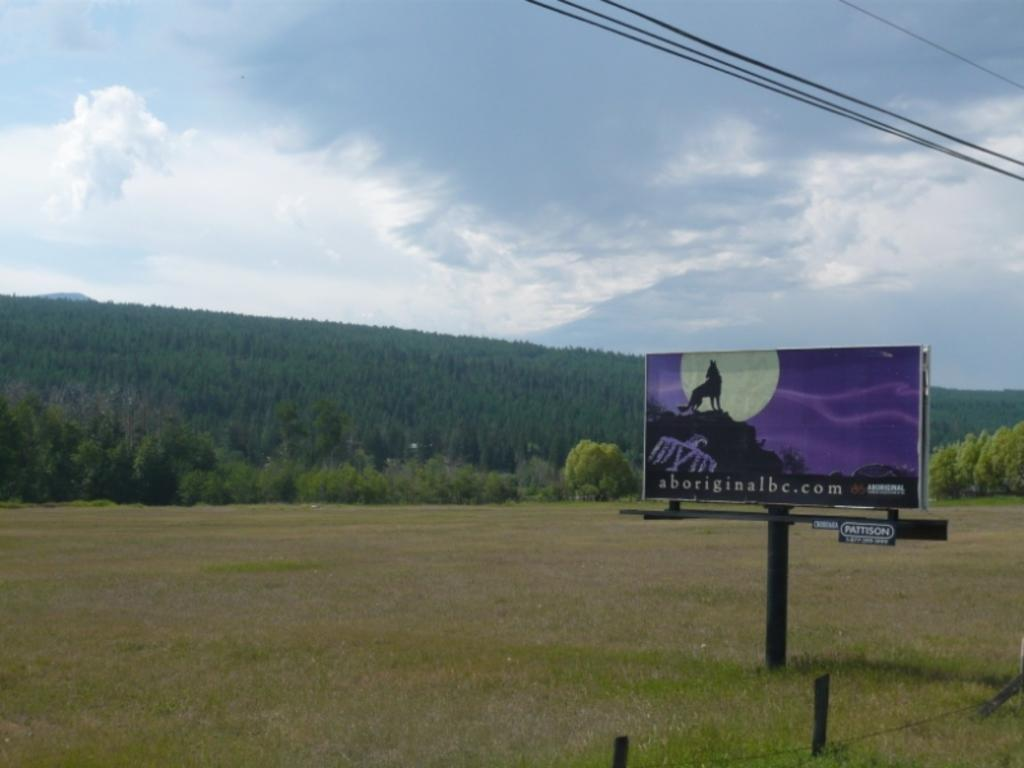What type of terrain is in the foreground of the image? There is grassland in the foreground of the image. What structures are present in the foreground of the image? There is a fence and a hoarding in the foreground of the image. What can be seen at the top of the image? Cables and the sky are visible at the top of the image. What type of vegetation is in the background of the image? There are trees in the background of the image. What organization is responsible for the creation of the trees in the background? There is no organization responsible for the creation of the trees in the background; trees grow naturally. What belief system is depicted in the image? There is no specific belief system depicted in the image; it is a landscape scene with grassland, a fence, a hoarding, cables, the sky, and trees. 